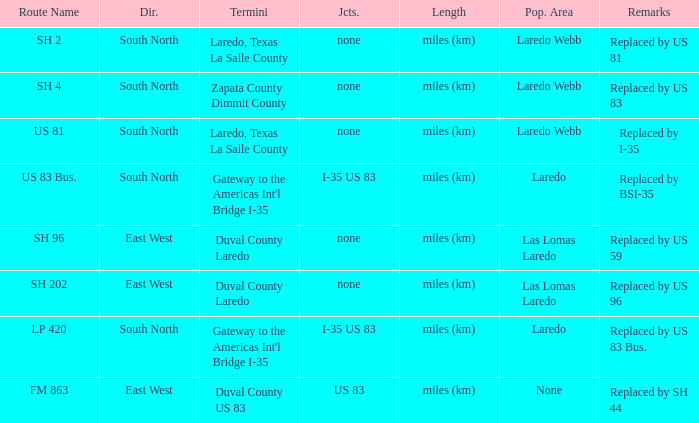Write the full table. {'header': ['Route Name', 'Dir.', 'Termini', 'Jcts.', 'Length', 'Pop. Area', 'Remarks'], 'rows': [['SH 2', 'South North', 'Laredo, Texas La Salle County', 'none', 'miles (km)', 'Laredo Webb', 'Replaced by US 81'], ['SH 4', 'South North', 'Zapata County Dimmit County', 'none', 'miles (km)', 'Laredo Webb', 'Replaced by US 83'], ['US 81', 'South North', 'Laredo, Texas La Salle County', 'none', 'miles (km)', 'Laredo Webb', 'Replaced by I-35'], ['US 83 Bus.', 'South North', "Gateway to the Americas Int'l Bridge I-35", 'I-35 US 83', 'miles (km)', 'Laredo', 'Replaced by BSI-35'], ['SH 96', 'East West', 'Duval County Laredo', 'none', 'miles (km)', 'Las Lomas Laredo', 'Replaced by US 59'], ['SH 202', 'East West', 'Duval County Laredo', 'none', 'miles (km)', 'Las Lomas Laredo', 'Replaced by US 96'], ['LP 420', 'South North', "Gateway to the Americas Int'l Bridge I-35", 'I-35 US 83', 'miles (km)', 'Laredo', 'Replaced by US 83 Bus.'], ['FM 863', 'East West', 'Duval County US 83', 'US 83', 'miles (km)', 'None', 'Replaced by SH 44']]} What unit of length is being used for the route with "replaced by us 81" in their remarks section? Miles (km). 